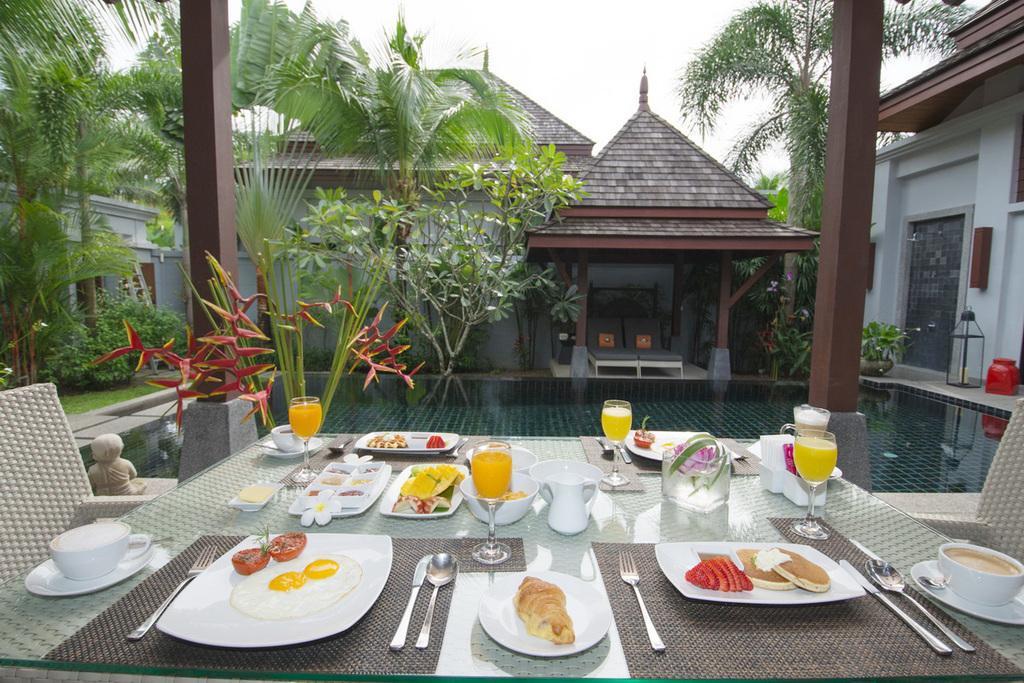How would you summarize this image in a sentence or two? In this image we can see few food items, glass of juice and a cup of tea, fork, spoons on the dining table, on the other side of the dining table we can see the swimming pool, trees and a house. 